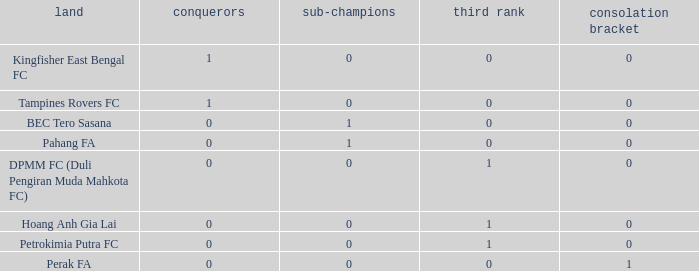Name the average 3rd place with winners of 0, 4th place of 0 and nation of pahang fa 0.0. 